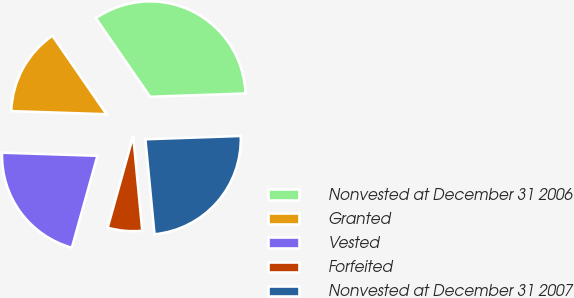<chart> <loc_0><loc_0><loc_500><loc_500><pie_chart><fcel>Nonvested at December 31 2006<fcel>Granted<fcel>Vested<fcel>Forfeited<fcel>Nonvested at December 31 2007<nl><fcel>34.06%<fcel>14.87%<fcel>21.2%<fcel>5.84%<fcel>24.03%<nl></chart> 